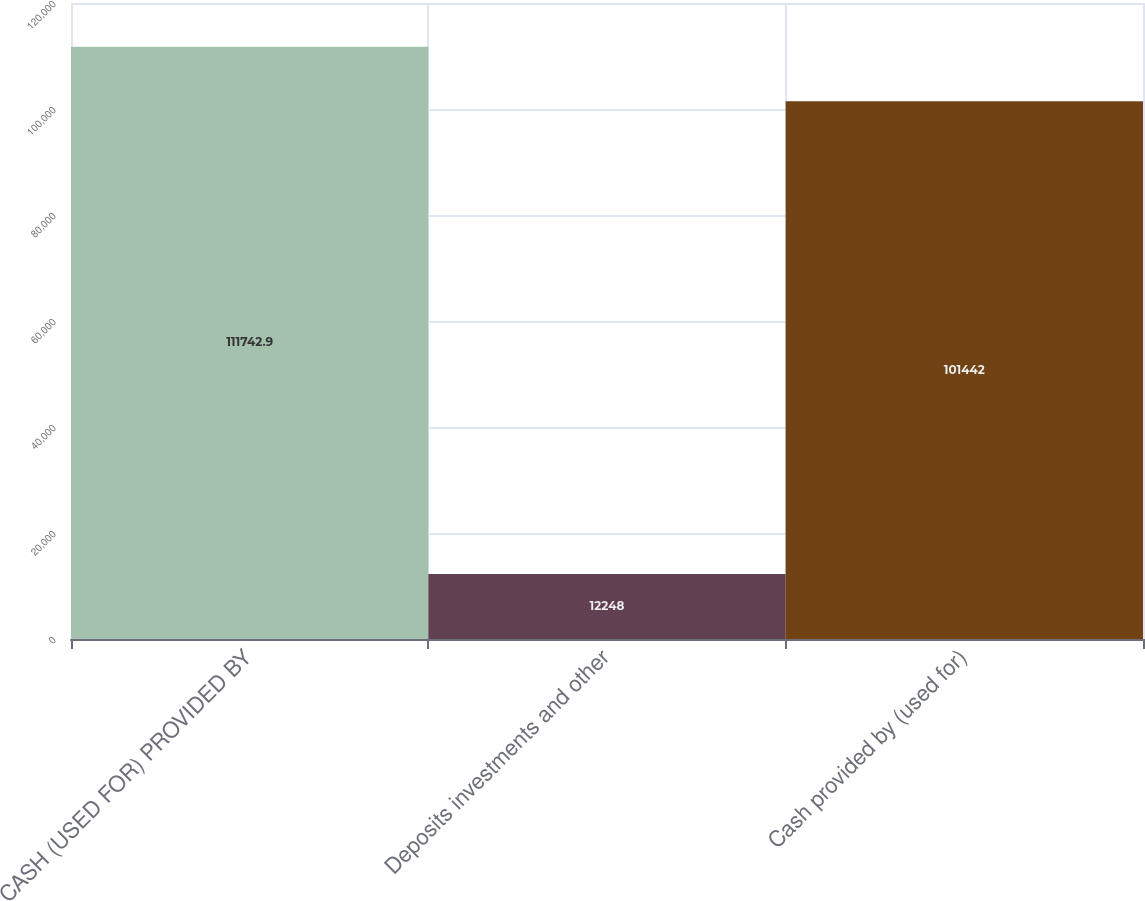Convert chart. <chart><loc_0><loc_0><loc_500><loc_500><bar_chart><fcel>CASH (USED FOR) PROVIDED BY<fcel>Deposits investments and other<fcel>Cash provided by (used for)<nl><fcel>111743<fcel>12248<fcel>101442<nl></chart> 